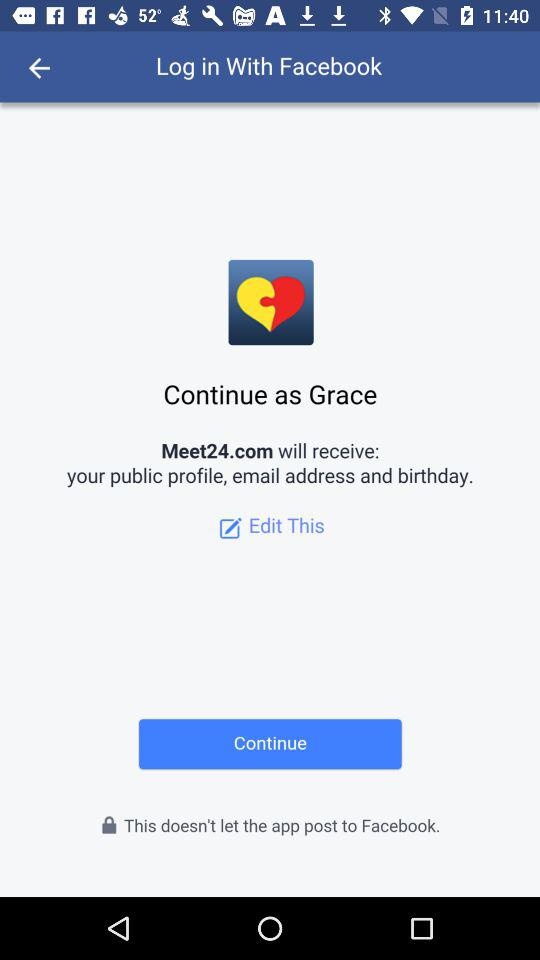What is the name of the user? The name of the user is Grace. 